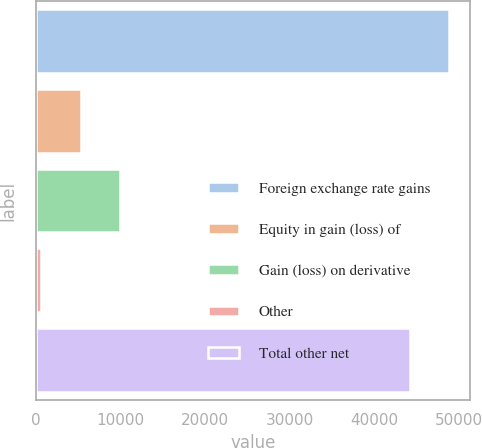Convert chart to OTSL. <chart><loc_0><loc_0><loc_500><loc_500><bar_chart><fcel>Foreign exchange rate gains<fcel>Equity in gain (loss) of<fcel>Gain (loss) on derivative<fcel>Other<fcel>Total other net<nl><fcel>48823.9<fcel>5315.9<fcel>9961.8<fcel>670<fcel>44178<nl></chart> 